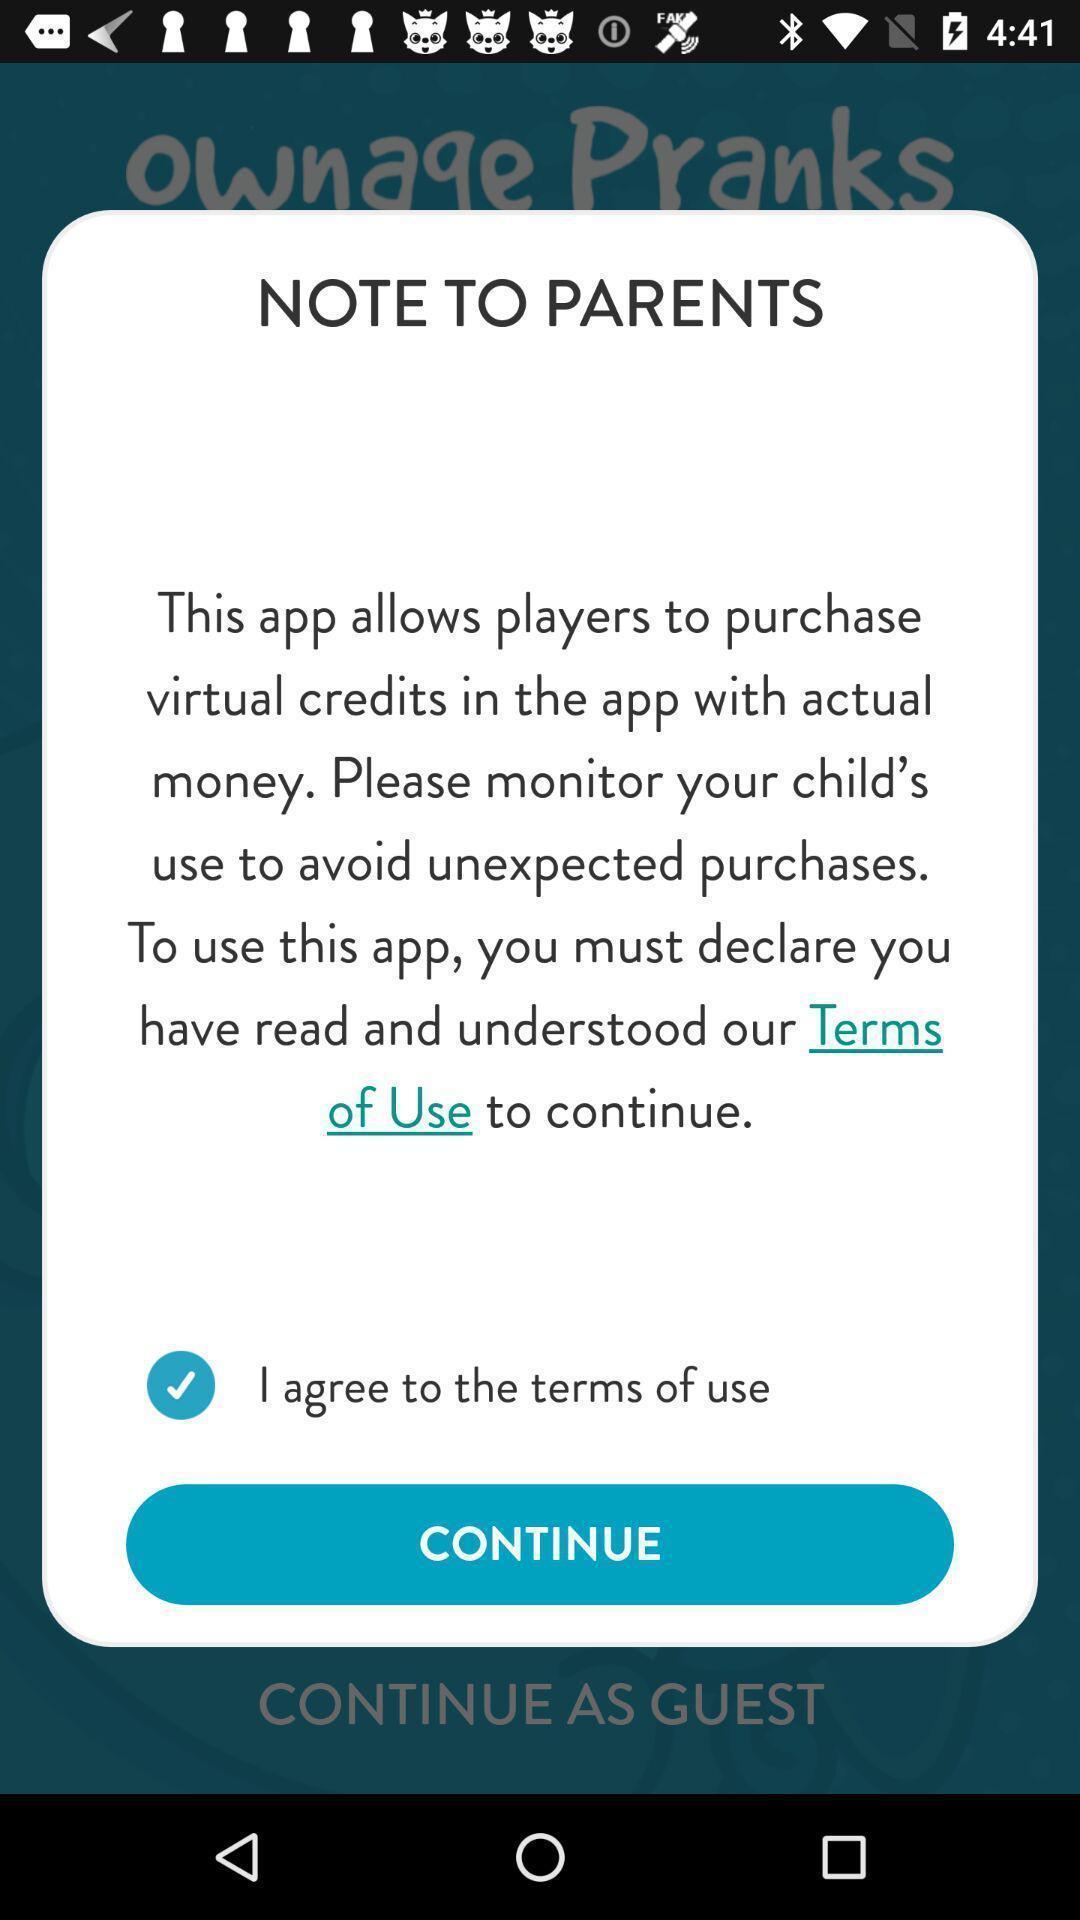Explain what's happening in this screen capture. Popup showing note to parents and some information in app. 